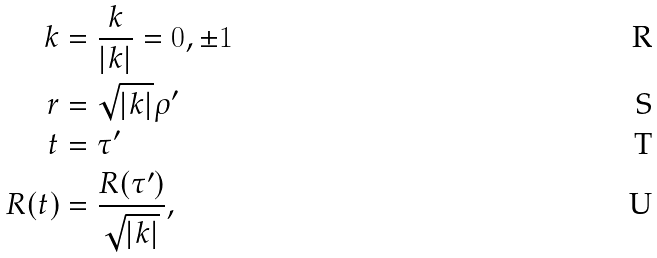Convert formula to latex. <formula><loc_0><loc_0><loc_500><loc_500>k & = \frac { k } { \left | k \right | } = 0 , \pm 1 \\ r & = \sqrt { \left | k \right | } \rho ^ { \prime } \\ t & = \tau ^ { \prime } \\ R ( t ) & = \frac { R ( \tau ^ { \prime } ) } { \sqrt { \left | k \right | } } ,</formula> 